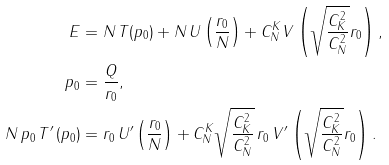Convert formula to latex. <formula><loc_0><loc_0><loc_500><loc_500>E & = N \, T ( p _ { 0 } ) + N \, U \left ( \frac { r _ { 0 } } { N } \right ) + C _ { N } ^ { K } V \left ( \sqrt { \frac { C _ { K } ^ { 2 } } { C _ { N } ^ { 2 } } } r _ { 0 } \right ) , \\ p _ { 0 } & = \frac { Q } { r _ { 0 } } , \\ N \, p _ { 0 } \, T ^ { \prime } \left ( p _ { 0 } \right ) & = r _ { 0 } \, U ^ { \prime } \left ( \frac { r _ { 0 } } { N } \right ) + C _ { N } ^ { K } \sqrt { \frac { C _ { K } ^ { 2 } } { C _ { N } ^ { 2 } } } \, r _ { 0 } \, V ^ { \prime } \left ( \sqrt { \frac { C _ { K } ^ { 2 } } { C _ { N } ^ { 2 } } } r _ { 0 } \right ) .</formula> 